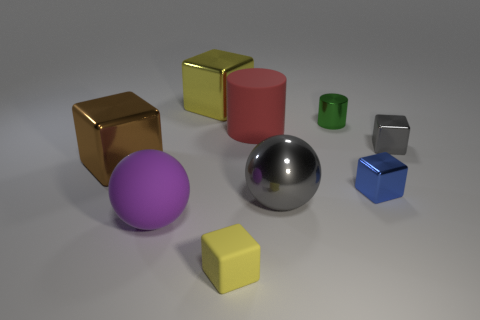Is the number of small cubes on the left side of the yellow rubber thing less than the number of large brown things?
Offer a terse response. Yes. How many shiny objects have the same color as the metal ball?
Provide a short and direct response. 1. What is the size of the gray metallic object that is behind the big gray metal thing?
Offer a very short reply. Small. There is a gray thing in front of the large cube on the left side of the shiny block behind the tiny cylinder; what shape is it?
Offer a terse response. Sphere. There is a matte thing that is both in front of the large brown metal block and right of the big matte sphere; what shape is it?
Ensure brevity in your answer.  Cube. Is there a yellow object that has the same size as the green shiny cylinder?
Your response must be concise. Yes. Does the small thing in front of the large purple matte ball have the same shape as the brown metal object?
Your response must be concise. Yes. Do the tiny green thing and the red rubber object have the same shape?
Offer a terse response. Yes. Are there any tiny yellow objects that have the same shape as the blue metal thing?
Provide a succinct answer. Yes. There is a big metallic object that is behind the brown object on the left side of the tiny blue thing; what shape is it?
Offer a terse response. Cube. 